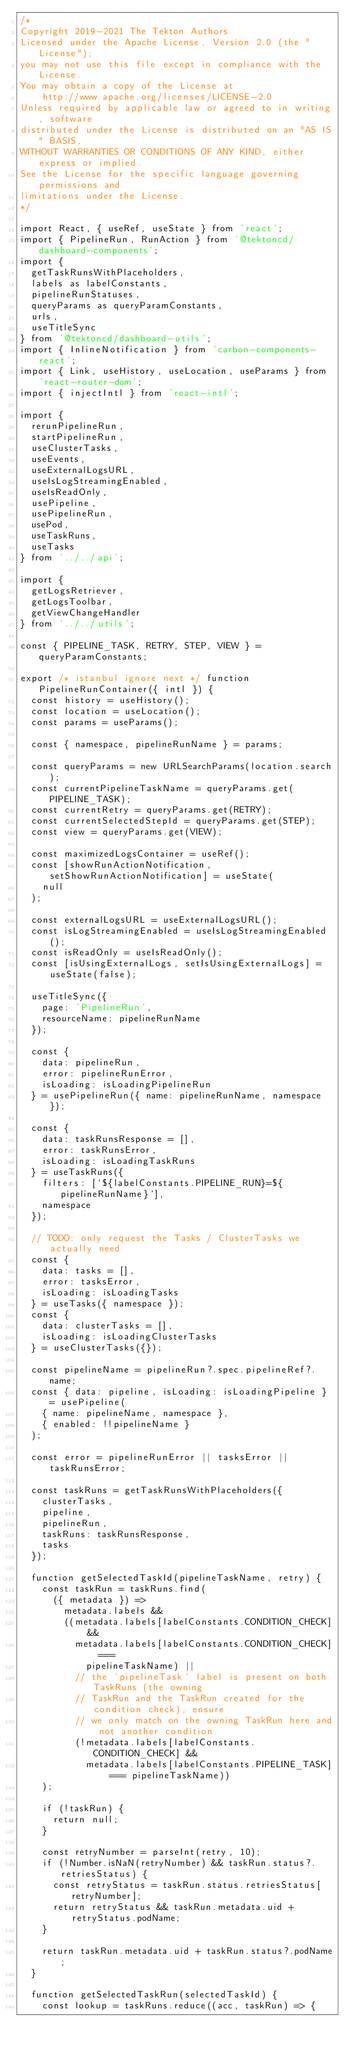Convert code to text. <code><loc_0><loc_0><loc_500><loc_500><_JavaScript_>/*
Copyright 2019-2021 The Tekton Authors
Licensed under the Apache License, Version 2.0 (the "License");
you may not use this file except in compliance with the License.
You may obtain a copy of the License at
    http://www.apache.org/licenses/LICENSE-2.0
Unless required by applicable law or agreed to in writing, software
distributed under the License is distributed on an "AS IS" BASIS,
WITHOUT WARRANTIES OR CONDITIONS OF ANY KIND, either express or implied.
See the License for the specific language governing permissions and
limitations under the License.
*/

import React, { useRef, useState } from 'react';
import { PipelineRun, RunAction } from '@tektoncd/dashboard-components';
import {
  getTaskRunsWithPlaceholders,
  labels as labelConstants,
  pipelineRunStatuses,
  queryParams as queryParamConstants,
  urls,
  useTitleSync
} from '@tektoncd/dashboard-utils';
import { InlineNotification } from 'carbon-components-react';
import { Link, useHistory, useLocation, useParams } from 'react-router-dom';
import { injectIntl } from 'react-intl';

import {
  rerunPipelineRun,
  startPipelineRun,
  useClusterTasks,
  useEvents,
  useExternalLogsURL,
  useIsLogStreamingEnabled,
  useIsReadOnly,
  usePipeline,
  usePipelineRun,
  usePod,
  useTaskRuns,
  useTasks
} from '../../api';

import {
  getLogsRetriever,
  getLogsToolbar,
  getViewChangeHandler
} from '../../utils';

const { PIPELINE_TASK, RETRY, STEP, VIEW } = queryParamConstants;

export /* istanbul ignore next */ function PipelineRunContainer({ intl }) {
  const history = useHistory();
  const location = useLocation();
  const params = useParams();

  const { namespace, pipelineRunName } = params;

  const queryParams = new URLSearchParams(location.search);
  const currentPipelineTaskName = queryParams.get(PIPELINE_TASK);
  const currentRetry = queryParams.get(RETRY);
  const currentSelectedStepId = queryParams.get(STEP);
  const view = queryParams.get(VIEW);

  const maximizedLogsContainer = useRef();
  const [showRunActionNotification, setShowRunActionNotification] = useState(
    null
  );

  const externalLogsURL = useExternalLogsURL();
  const isLogStreamingEnabled = useIsLogStreamingEnabled();
  const isReadOnly = useIsReadOnly();
  const [isUsingExternalLogs, setIsUsingExternalLogs] = useState(false);

  useTitleSync({
    page: 'PipelineRun',
    resourceName: pipelineRunName
  });

  const {
    data: pipelineRun,
    error: pipelineRunError,
    isLoading: isLoadingPipelineRun
  } = usePipelineRun({ name: pipelineRunName, namespace });

  const {
    data: taskRunsResponse = [],
    error: taskRunsError,
    isLoading: isLoadingTaskRuns
  } = useTaskRuns({
    filters: [`${labelConstants.PIPELINE_RUN}=${pipelineRunName}`],
    namespace
  });

  // TODO: only request the Tasks / ClusterTasks we actually need
  const {
    data: tasks = [],
    error: tasksError,
    isLoading: isLoadingTasks
  } = useTasks({ namespace });
  const {
    data: clusterTasks = [],
    isLoading: isLoadingClusterTasks
  } = useClusterTasks({});

  const pipelineName = pipelineRun?.spec.pipelineRef?.name;
  const { data: pipeline, isLoading: isLoadingPipeline } = usePipeline(
    { name: pipelineName, namespace },
    { enabled: !!pipelineName }
  );

  const error = pipelineRunError || tasksError || taskRunsError;

  const taskRuns = getTaskRunsWithPlaceholders({
    clusterTasks,
    pipeline,
    pipelineRun,
    taskRuns: taskRunsResponse,
    tasks
  });

  function getSelectedTaskId(pipelineTaskName, retry) {
    const taskRun = taskRuns.find(
      ({ metadata }) =>
        metadata.labels &&
        ((metadata.labels[labelConstants.CONDITION_CHECK] &&
          metadata.labels[labelConstants.CONDITION_CHECK] ===
            pipelineTaskName) ||
          // the `pipelineTask` label is present on both TaskRuns (the owning
          // TaskRun and the TaskRun created for the condition check), ensure
          // we only match on the owning TaskRun here and not another condition
          (!metadata.labels[labelConstants.CONDITION_CHECK] &&
            metadata.labels[labelConstants.PIPELINE_TASK] === pipelineTaskName))
    );

    if (!taskRun) {
      return null;
    }

    const retryNumber = parseInt(retry, 10);
    if (!Number.isNaN(retryNumber) && taskRun.status?.retriesStatus) {
      const retryStatus = taskRun.status.retriesStatus[retryNumber];
      return retryStatus && taskRun.metadata.uid + retryStatus.podName;
    }

    return taskRun.metadata.uid + taskRun.status?.podName;
  }

  function getSelectedTaskRun(selectedTaskId) {
    const lookup = taskRuns.reduce((acc, taskRun) => {</code> 